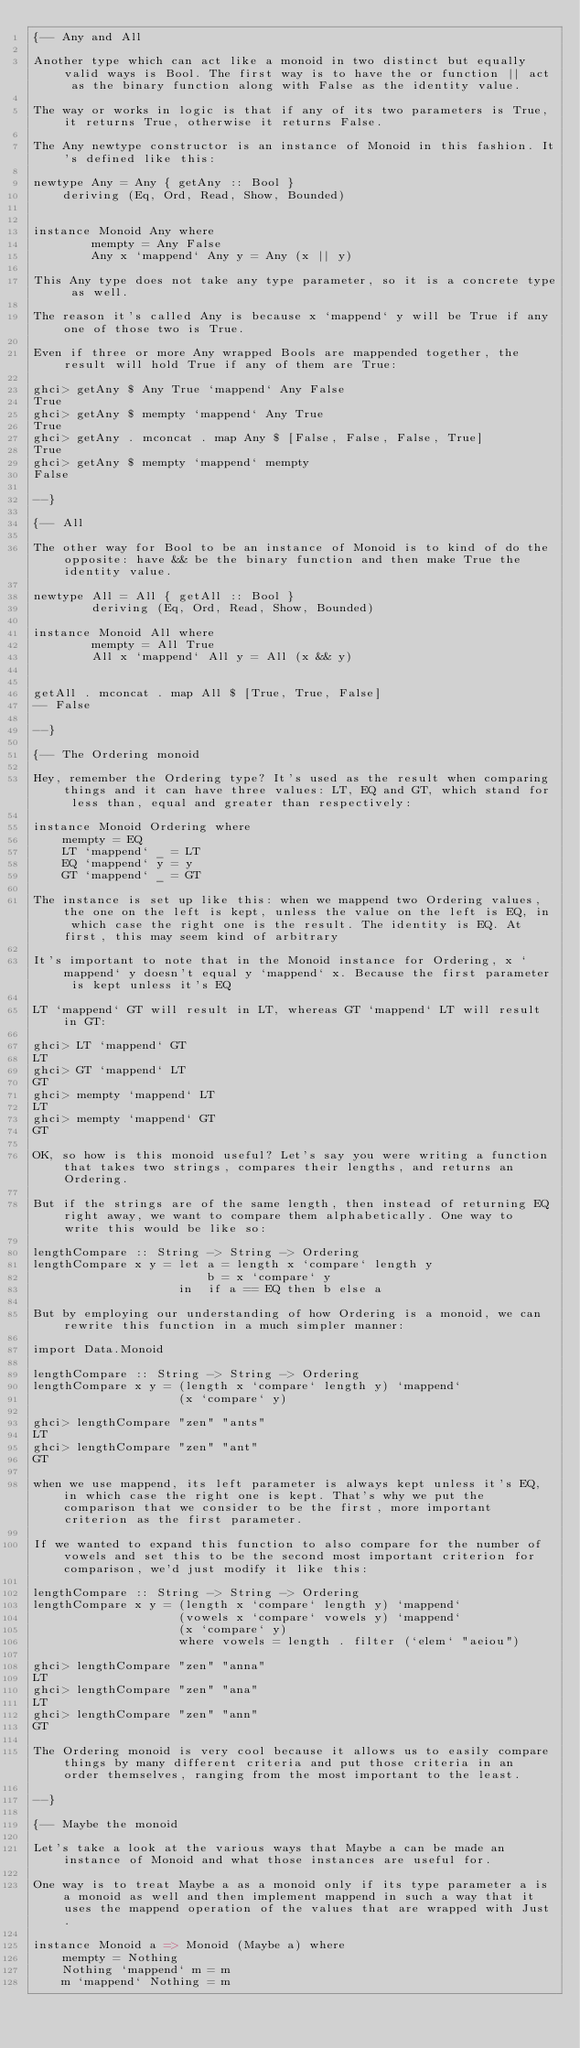<code> <loc_0><loc_0><loc_500><loc_500><_Haskell_>{-- Any and All

Another type which can act like a monoid in two distinct but equally valid ways is Bool. The first way is to have the or function || act as the binary function along with False as the identity value.

The way or works in logic is that if any of its two parameters is True, it returns True, otherwise it returns False.

The Any newtype constructor is an instance of Monoid in this fashion. It's defined like this:

newtype Any = Any { getAny :: Bool }
    deriving (Eq, Ord, Read, Show, Bounded)


instance Monoid Any where
        mempty = Any False
        Any x `mappend` Any y = Any (x || y)

This Any type does not take any type parameter, so it is a concrete type as well.

The reason it's called Any is because x `mappend` y will be True if any one of those two is True.

Even if three or more Any wrapped Bools are mappended together, the result will hold True if any of them are True:

ghci> getAny $ Any True `mappend` Any False
True
ghci> getAny $ mempty `mappend` Any True
True
ghci> getAny . mconcat . map Any $ [False, False, False, True]
True
ghci> getAny $ mempty `mappend` mempty
False

--}

{-- All

The other way for Bool to be an instance of Monoid is to kind of do the opposite: have && be the binary function and then make True the identity value.

newtype All = All { getAll :: Bool }
        deriving (Eq, Ord, Read, Show, Bounded)

instance Monoid All where
        mempty = All True
        All x `mappend` All y = All (x && y)


getAll . mconcat . map All $ [True, True, False]
-- False

--}

{-- The Ordering monoid

Hey, remember the Ordering type? It's used as the result when comparing things and it can have three values: LT, EQ and GT, which stand for less than, equal and greater than respectively:

instance Monoid Ordering where
    mempty = EQ
    LT `mappend` _ = LT
    EQ `mappend` y = y
    GT `mappend` _ = GT

The instance is set up like this: when we mappend two Ordering values, the one on the left is kept, unless the value on the left is EQ, in which case the right one is the result. The identity is EQ. At first, this may seem kind of arbitrary

It's important to note that in the Monoid instance for Ordering, x `mappend` y doesn't equal y `mappend` x. Because the first parameter is kept unless it's EQ

LT `mappend` GT will result in LT, whereas GT `mappend` LT will result in GT:

ghci> LT `mappend` GT
LT
ghci> GT `mappend` LT
GT
ghci> mempty `mappend` LT
LT
ghci> mempty `mappend` GT
GT

OK, so how is this monoid useful? Let's say you were writing a function that takes two strings, compares their lengths, and returns an Ordering.

But if the strings are of the same length, then instead of returning EQ right away, we want to compare them alphabetically. One way to write this would be like so:

lengthCompare :: String -> String -> Ordering
lengthCompare x y = let a = length x `compare` length y
                        b = x `compare` y
                    in  if a == EQ then b else a

But by employing our understanding of how Ordering is a monoid, we can rewrite this function in a much simpler manner:

import Data.Monoid

lengthCompare :: String -> String -> Ordering
lengthCompare x y = (length x `compare` length y) `mappend`
                    (x `compare` y)

ghci> lengthCompare "zen" "ants"
LT
ghci> lengthCompare "zen" "ant"
GT

when we use mappend, its left parameter is always kept unless it's EQ, in which case the right one is kept. That's why we put the comparison that we consider to be the first, more important criterion as the first parameter.

If we wanted to expand this function to also compare for the number of vowels and set this to be the second most important criterion for comparison, we'd just modify it like this:

lengthCompare :: String -> String -> Ordering
lengthCompare x y = (length x `compare` length y) `mappend`
                    (vowels x `compare` vowels y) `mappend`
                    (x `compare` y)
                    where vowels = length . filter (`elem` "aeiou")

ghci> lengthCompare "zen" "anna"
LT
ghci> lengthCompare "zen" "ana"
LT
ghci> lengthCompare "zen" "ann"
GT

The Ordering monoid is very cool because it allows us to easily compare things by many different criteria and put those criteria in an order themselves, ranging from the most important to the least.

--}

{-- Maybe the monoid

Let's take a look at the various ways that Maybe a can be made an instance of Monoid and what those instances are useful for.

One way is to treat Maybe a as a monoid only if its type parameter a is a monoid as well and then implement mappend in such a way that it uses the mappend operation of the values that are wrapped with Just.

instance Monoid a => Monoid (Maybe a) where
    mempty = Nothing
    Nothing `mappend` m = m
    m `mappend` Nothing = m</code> 